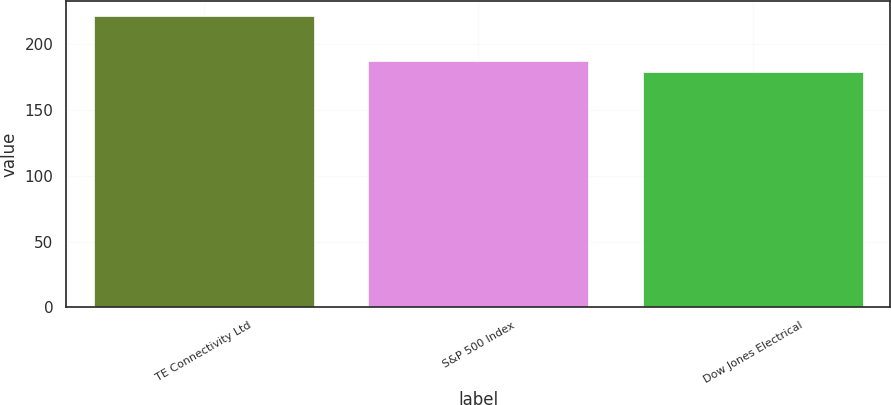Convert chart to OTSL. <chart><loc_0><loc_0><loc_500><loc_500><bar_chart><fcel>TE Connectivity Ltd<fcel>S&P 500 Index<fcel>Dow Jones Electrical<nl><fcel>221.28<fcel>186.88<fcel>178.41<nl></chart> 